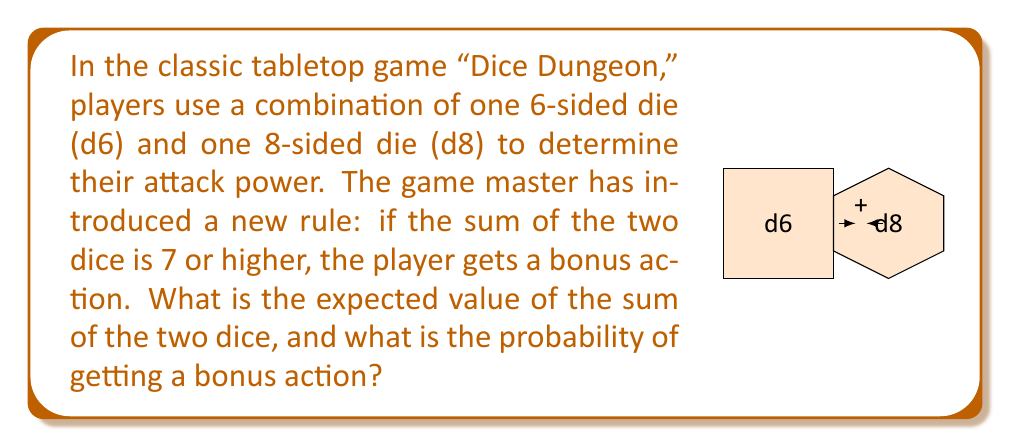Give your solution to this math problem. Let's approach this step-by-step:

1) First, we need to calculate the expected value of each die:
   
   For d6: $E(d6) = \frac{1+2+3+4+5+6}{6} = \frac{21}{6} = 3.5$
   For d8: $E(d8) = \frac{1+2+3+4+5+6+7+8}{8} = \frac{36}{8} = 4.5$

2) The expected value of the sum is the sum of the expected values:
   
   $E(d6 + d8) = E(d6) + E(d8) = 3.5 + 4.5 = 8$

3) Now, for the probability of getting a bonus action (sum ≥ 7):
   
   We need to count favorable outcomes:
   (1,6), (1,7), (1,8)
   (2,5), (2,6), (2,7), (2,8)
   (3,4), (3,5), (3,6), (3,7), (3,8)
   (4,3), (4,4), (4,5), (4,6), (4,7), (4,8)
   (5,2), (5,3), (5,4), (5,5), (5,6), (5,7), (5,8)
   (6,1), (6,2), (6,3), (6,4), (6,5), (6,6), (6,7), (6,8)

4) Count of favorable outcomes: 3 + 4 + 5 + 6 + 7 + 8 = 33

5) Total possible outcomes: $6 * 8 = 48$

6) Probability of bonus action: $P(\text{sum} \geq 7) = \frac{33}{48} = \frac{11}{16} = 0.6875 = 68.75\%$
Answer: Expected value: 8; Probability of bonus action: $\frac{11}{16}$ or 68.75% 